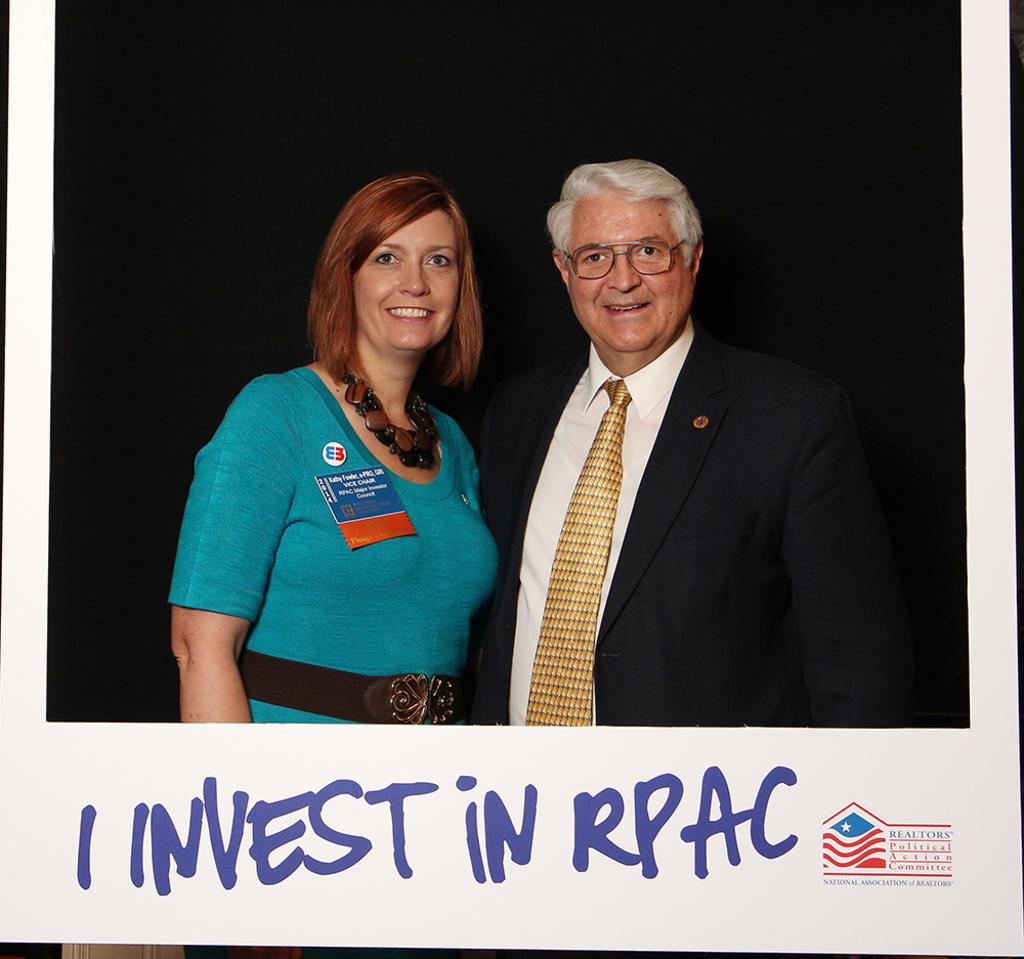Provide a one-sentence caption for the provided image. Two people posing for a photo with the words I Invest in RPAC below them. 